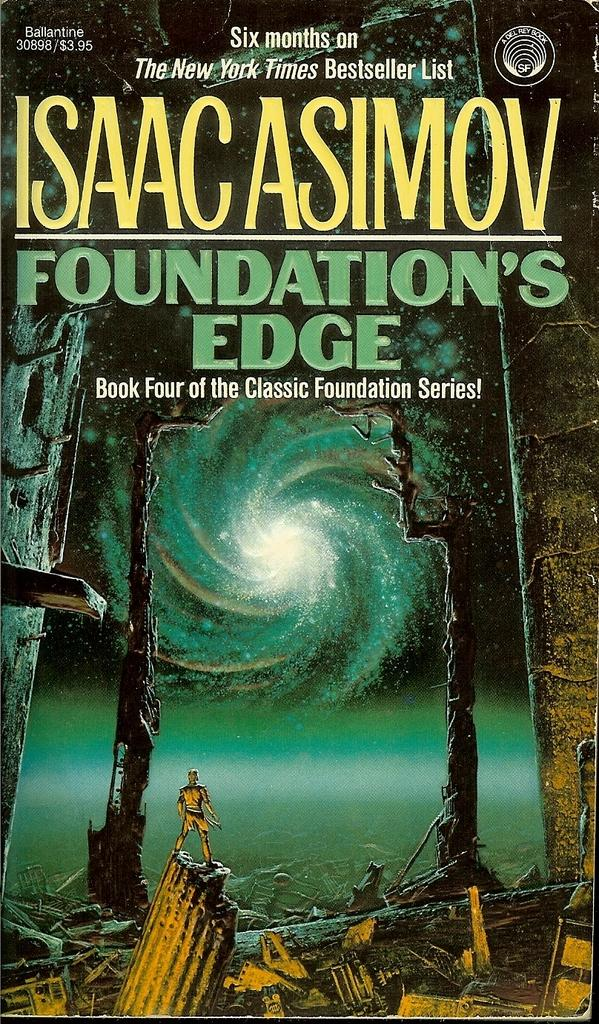<image>
Create a compact narrative representing the image presented. A book called Foundation's Edge by Isaac Asimov. 